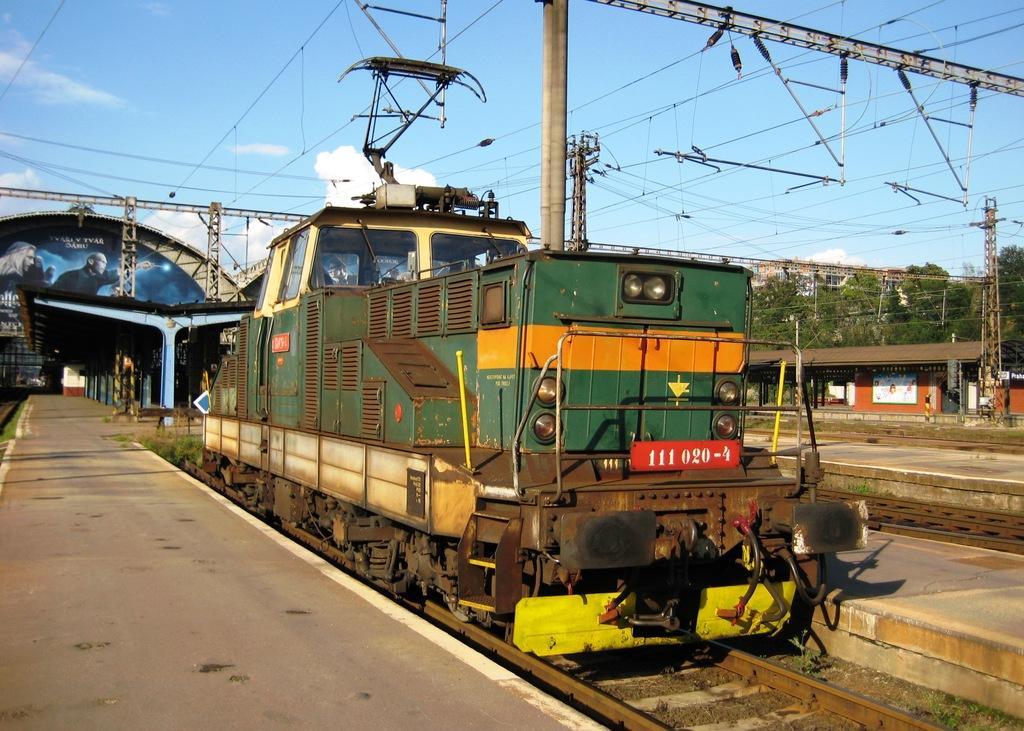Describe this image in one or two sentences. In the center of the image there is a train on the railway track. On the right side of the image we can see trees, platform, person's, current pole and railway tracks. On the left side of the image we can see station, platform, current pole and railway track. In the background there is a sky and clouds. 